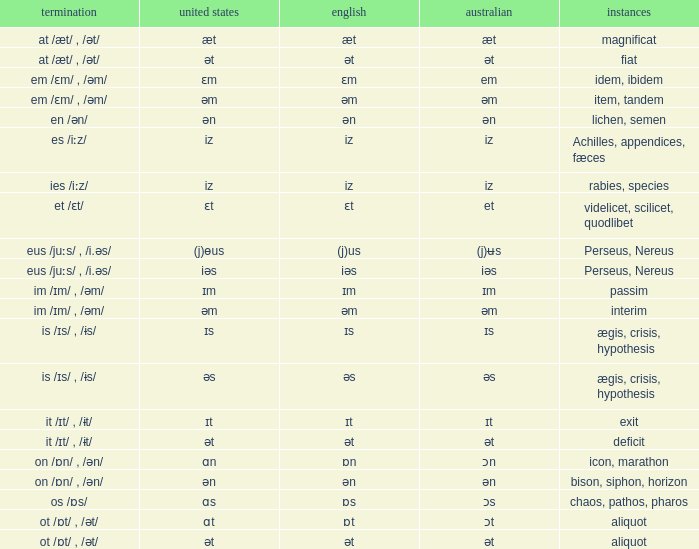Which American has British of ɛm? Ɛm. 